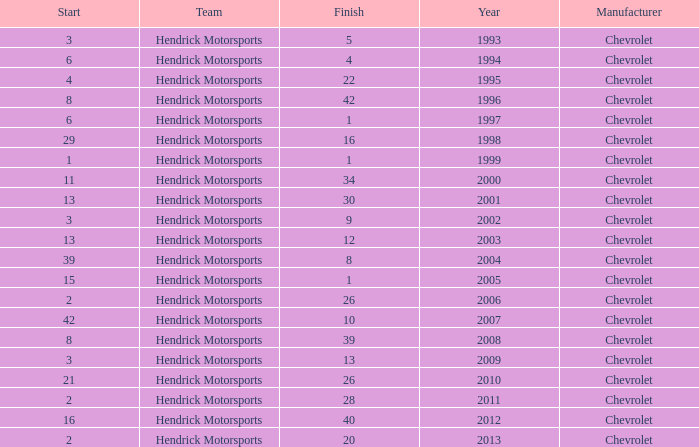What is the number of finishes having a start of 15? 1.0. 